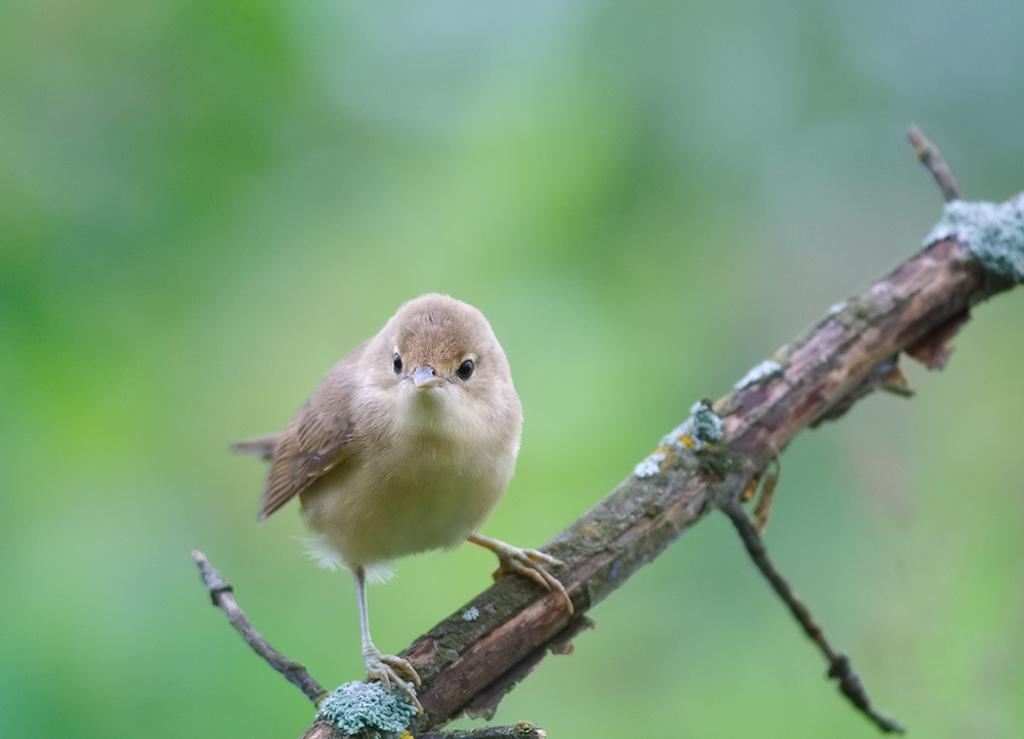What type of bird is in the image? There is a sparrow in the image. Where is the sparrow located? The sparrow is on a stem. Can you describe the background of the image? The background of the image is blurred. What month does the fireman mention in the image? There is no fireman present in the image, and therefore no mention of a month. 